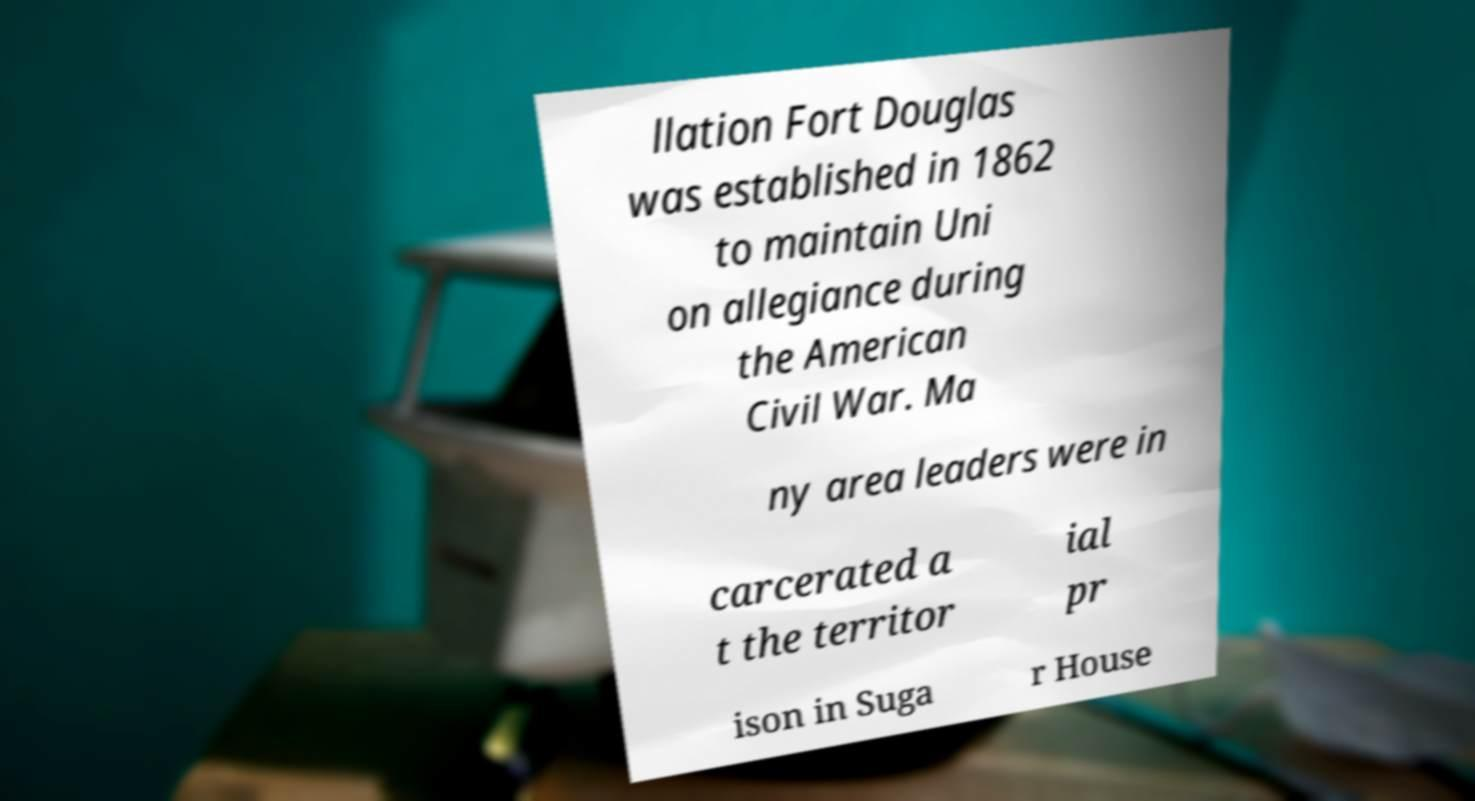Can you read and provide the text displayed in the image?This photo seems to have some interesting text. Can you extract and type it out for me? llation Fort Douglas was established in 1862 to maintain Uni on allegiance during the American Civil War. Ma ny area leaders were in carcerated a t the territor ial pr ison in Suga r House 